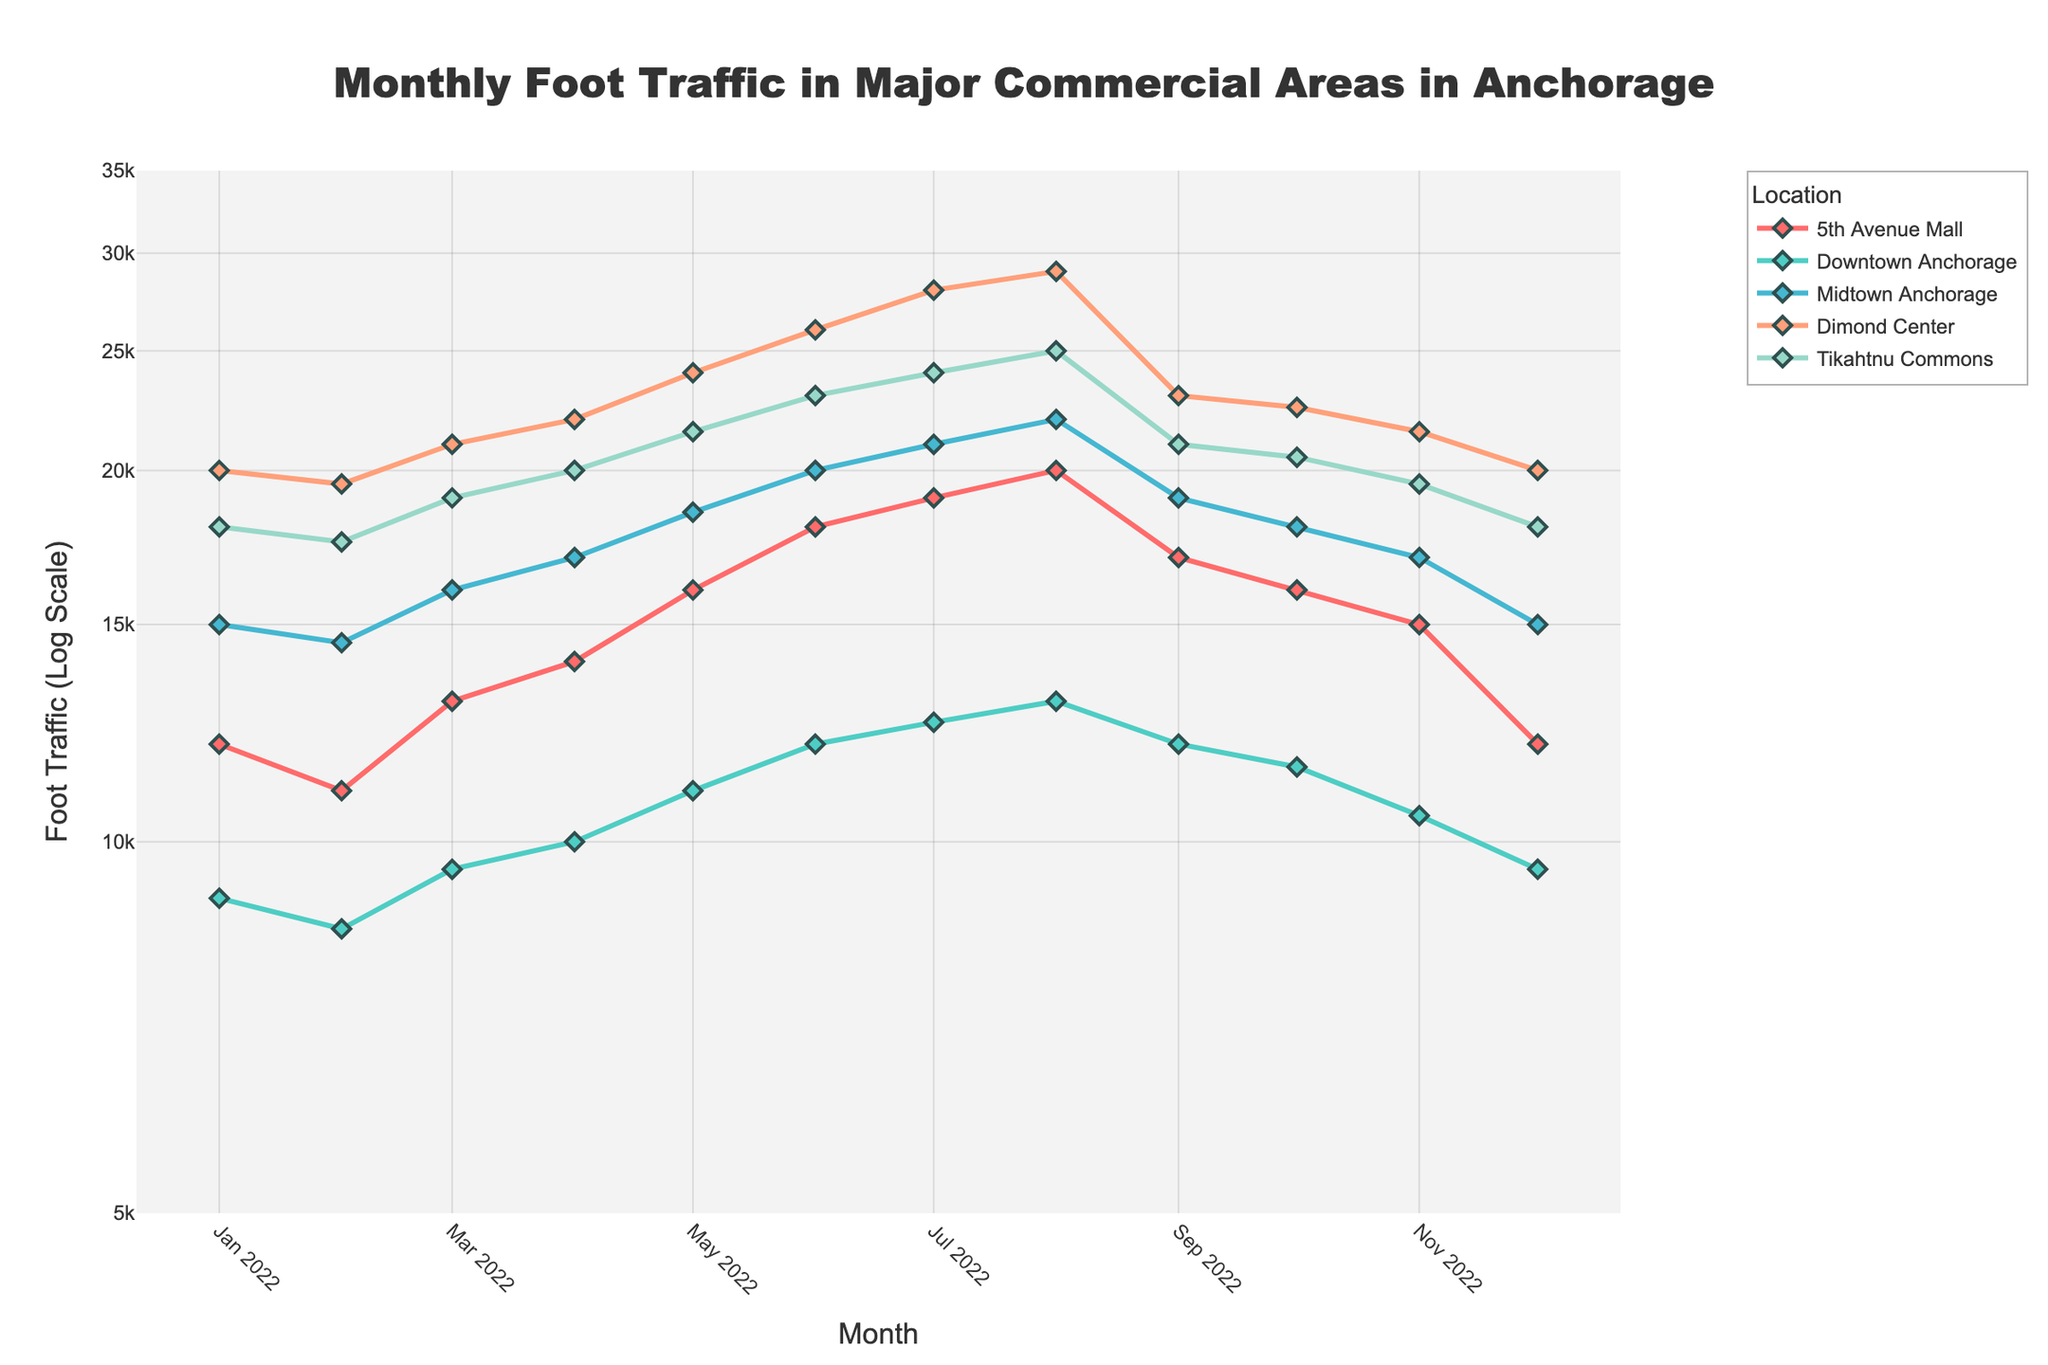What is the title of the plot? The title of the plot is located at the top center, above the chart. It reads "Monthly Foot Traffic in Major Commercial Areas in Anchorage".
Answer: Monthly Foot Traffic in Major Commercial Areas in Anchorage What is the y-axis representing, and what is unique about it? The y-axis represents Foot Traffic and uses a log scale, making it unique because the intervals between the ticks increase exponentially.
Answer: Foot Traffic (Log Scale) Which location had the highest foot traffic in July 2022? By looking at the markers for July 2022, the highest point is for Dimond Center.
Answer: Dimond Center How does the foot traffic at 5th Avenue Mall in March 2022 compare to that in September 2022? The foot traffic in 5th Avenue Mall is higher in March 2022 than in September 2022. In March 2022, the value is 13,000, whereas it is 17,000 in September 2022.
Answer: Higher What is the difference in foot traffic between Tikahtnu Commons and Downtown Anchorage in August 2022? In August 2022, Tikahtnu Commons has 25,000 visitors, and Downtown Anchorage has 13,000. The difference is 25,000 - 13,000 = 12,000.
Answer: 12,000 What is the overall trend of foot traffic in Midtown Anchorage throughout 2022? Observing the line connecting the markers for Midtown Anchorage throughout 2022, the general trend is an increase in foot traffic until August, followed by a decline towards December. The curve starts at 15,000 in January and peaks at 22,000 in August, then declines to 15,000 in December.
Answer: Increase then decrease In which month(s) did the foot traffic in Downtown Anchorage surpass 5th Avenue Mall? Comparing the foot traffic values month by month for Downtown Anchorage and 5th Avenue Mall, Downtown Anchorage only surpasses 5th Avenue Mall in January, February, and December.
Answer: January, February, December Which commercial area shows the widest range of foot traffic over the year? By observing the variation in foot traffic for each commercial area, Dimond Center shows the widest range, varying from about 20,000 to 29,000.
Answer: Dimond Center What was the general trend of foot traffic in Tikahtnu Commons during the year 2022? The line for Tikahtnu Commons generally trends upwards throughout the year, with foot traffic increasing from January to August and then decreasing slightly towards December.
Answer: Upwards then slightly downwards Between which two consecutive months does 5th Avenue Mall experience the highest increase in foot traffic? Observing the line graph for 5th Avenue Mall, the highest increase is between May and June, where it increases from 16,000 to 18,000.
Answer: May to June 